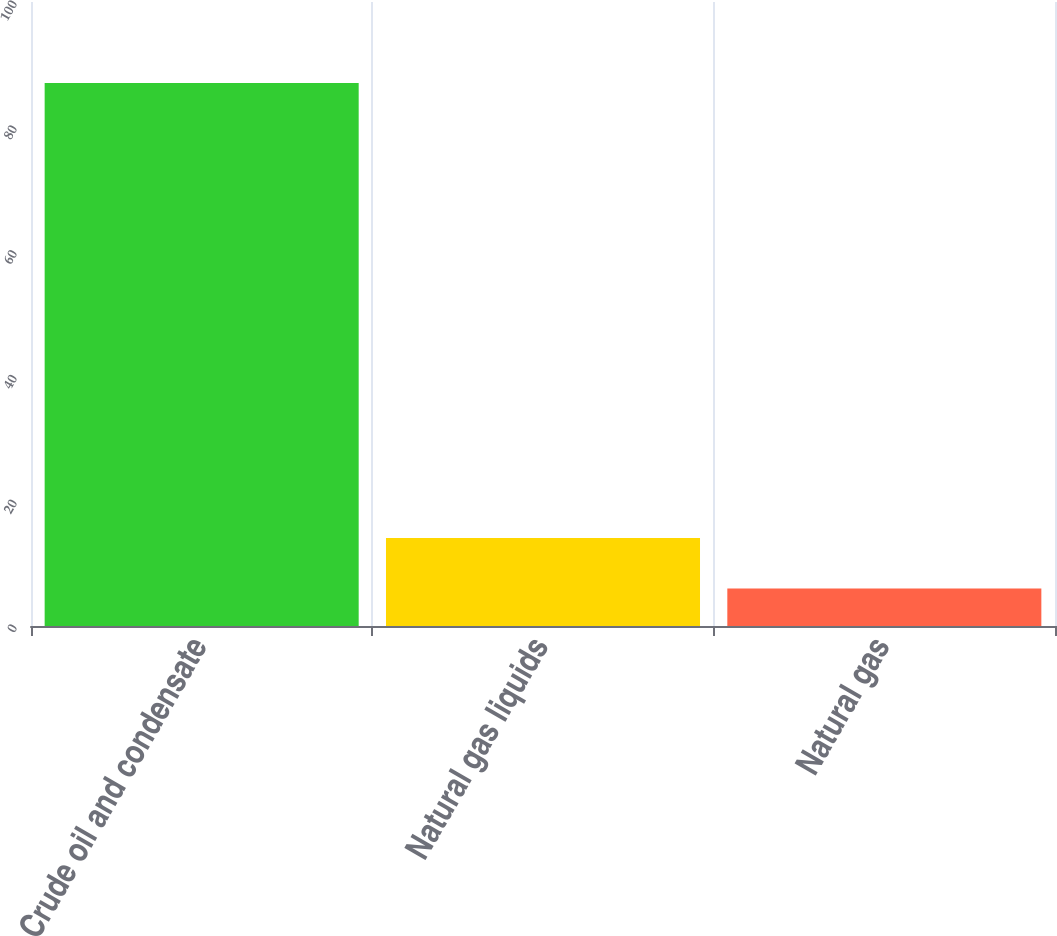Convert chart to OTSL. <chart><loc_0><loc_0><loc_500><loc_500><bar_chart><fcel>Crude oil and condensate<fcel>Natural gas liquids<fcel>Natural gas<nl><fcel>87<fcel>14.1<fcel>6<nl></chart> 